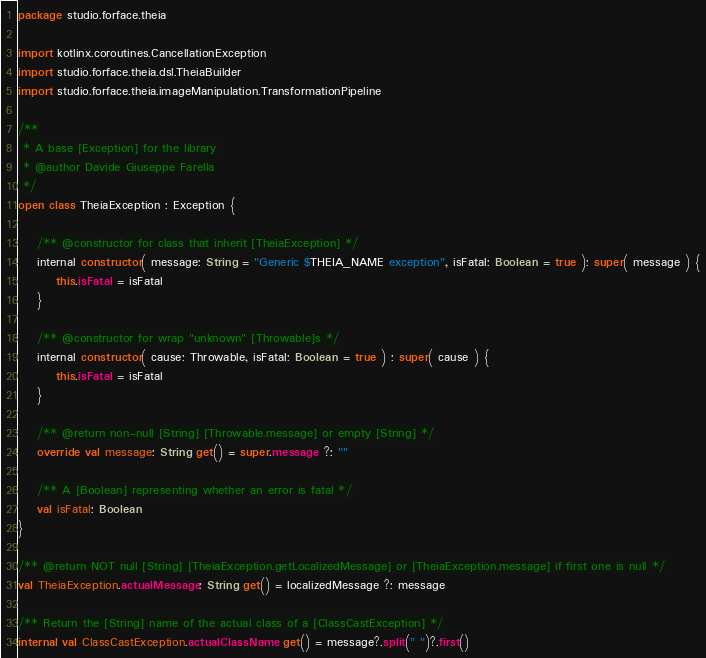<code> <loc_0><loc_0><loc_500><loc_500><_Kotlin_>package studio.forface.theia

import kotlinx.coroutines.CancellationException
import studio.forface.theia.dsl.TheiaBuilder
import studio.forface.theia.imageManipulation.TransformationPipeline

/**
 * A base [Exception] for the library
 * @author Davide Giuseppe Farella
 */
open class TheiaException : Exception {

    /** @constructor for class that inherit [TheiaException] */
    internal constructor( message: String = "Generic $THEIA_NAME exception", isFatal: Boolean = true ): super( message ) {
        this.isFatal = isFatal
    }

    /** @constructor for wrap "unknown" [Throwable]s */
    internal constructor( cause: Throwable, isFatal: Boolean = true ) : super( cause ) {
        this.isFatal = isFatal
    }

    /** @return non-null [String] [Throwable.message] or empty [String] */
    override val message: String get() = super.message ?: ""

    /** A [Boolean] representing whether an error is fatal */
    val isFatal: Boolean
}

/** @return NOT null [String] [TheiaException.getLocalizedMessage] or [TheiaException.message] if first one is null */
val TheiaException.actualMessage: String get() = localizedMessage ?: message

/** Return the [String] name of the actual class of a [ClassCastException] */
internal val ClassCastException.actualClassName get() = message?.split(" ")?.first()

</code> 